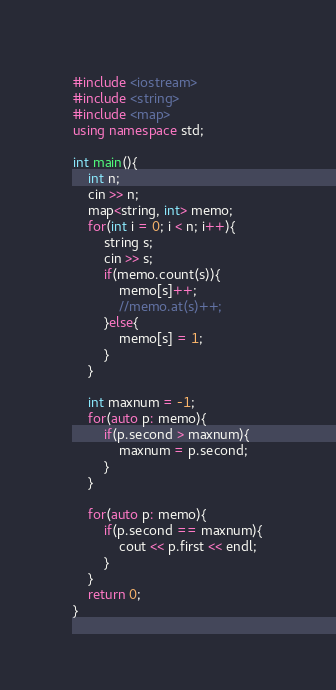<code> <loc_0><loc_0><loc_500><loc_500><_C++_>#include <iostream>
#include <string>
#include <map>
using namespace std;

int main(){
    int n;
    cin >> n;
    map<string, int> memo;
    for(int i = 0; i < n; i++){
        string s;
        cin >> s;
        if(memo.count(s)){
            memo[s]++;
            //memo.at(s)++;
        }else{
            memo[s] = 1;
        }
    }

    int maxnum = -1;
    for(auto p: memo){
        if(p.second > maxnum){
            maxnum = p.second;
        }
    }

    for(auto p: memo){
        if(p.second == maxnum){
            cout << p.first << endl;
        }
    }
    return 0;
}</code> 